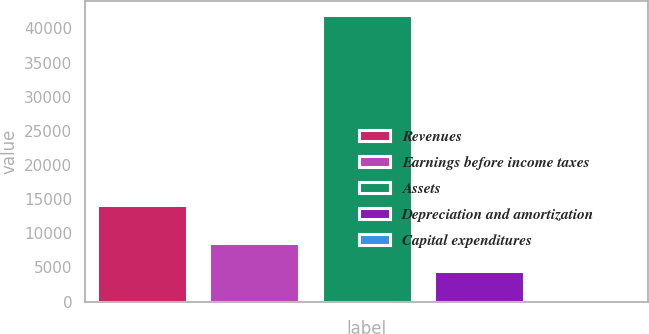Convert chart. <chart><loc_0><loc_0><loc_500><loc_500><bar_chart><fcel>Revenues<fcel>Earnings before income taxes<fcel>Assets<fcel>Depreciation and amortization<fcel>Capital expenditures<nl><fcel>14175.2<fcel>8576.74<fcel>41887.7<fcel>4412.87<fcel>249<nl></chart> 